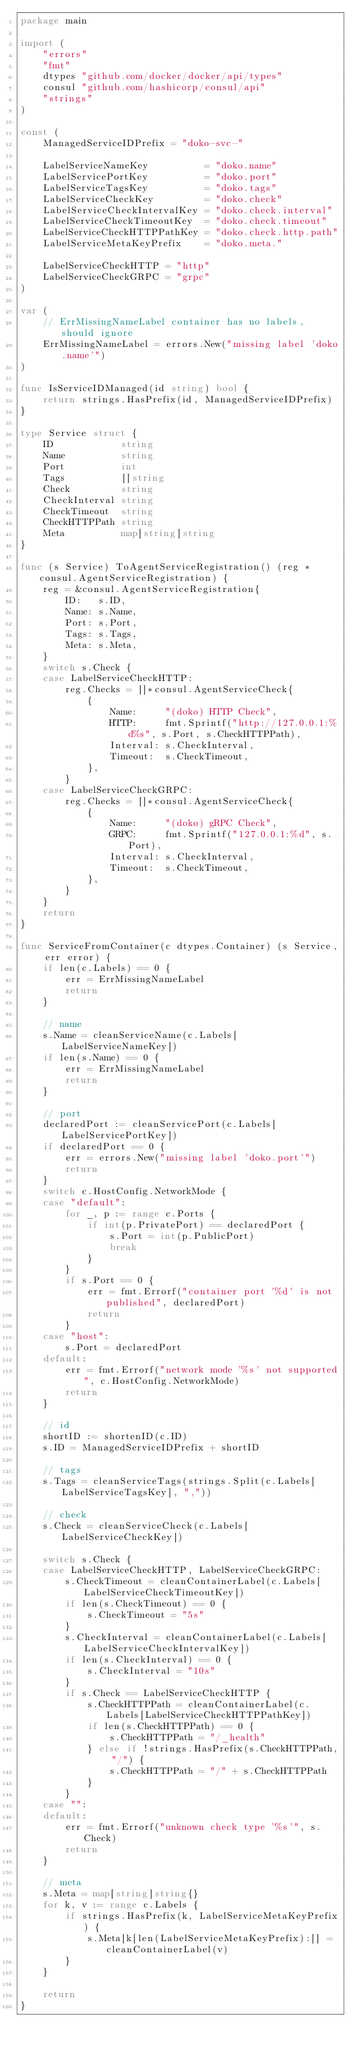Convert code to text. <code><loc_0><loc_0><loc_500><loc_500><_Go_>package main

import (
	"errors"
	"fmt"
	dtypes "github.com/docker/docker/api/types"
	consul "github.com/hashicorp/consul/api"
	"strings"
)

const (
	ManagedServiceIDPrefix = "doko-svc-"

	LabelServiceNameKey          = "doko.name"
	LabelServicePortKey          = "doko.port"
	LabelServiceTagsKey          = "doko.tags"
	LabelServiceCheckKey         = "doko.check"
	LabelServiceCheckIntervalKey = "doko.check.interval"
	LabelServiceCheckTimeoutKey  = "doko.check.timeout"
	LabelServiceCheckHTTPPathKey = "doko.check.http.path"
	LabelServiceMetaKeyPrefix    = "doko.meta."

	LabelServiceCheckHTTP = "http"
	LabelServiceCheckGRPC = "grpc"
)

var (
	// ErrMissingNameLabel container has no labels, should ignore
	ErrMissingNameLabel = errors.New("missing label 'doko.name'")
)

func IsServiceIDManaged(id string) bool {
	return strings.HasPrefix(id, ManagedServiceIDPrefix)
}

type Service struct {
	ID            string
	Name          string
	Port          int
	Tags          []string
	Check         string
	CheckInterval string
	CheckTimeout  string
	CheckHTTPPath string
	Meta          map[string]string
}

func (s Service) ToAgentServiceRegistration() (reg *consul.AgentServiceRegistration) {
	reg = &consul.AgentServiceRegistration{
		ID:   s.ID,
		Name: s.Name,
		Port: s.Port,
		Tags: s.Tags,
		Meta: s.Meta,
	}
	switch s.Check {
	case LabelServiceCheckHTTP:
		reg.Checks = []*consul.AgentServiceCheck{
			{
				Name:     "(doko) HTTP Check",
				HTTP:     fmt.Sprintf("http://127.0.0.1:%d%s", s.Port, s.CheckHTTPPath),
				Interval: s.CheckInterval,
				Timeout:  s.CheckTimeout,
			},
		}
	case LabelServiceCheckGRPC:
		reg.Checks = []*consul.AgentServiceCheck{
			{
				Name:     "(doko) gRPC Check",
				GRPC:     fmt.Sprintf("127.0.0.1:%d", s.Port),
				Interval: s.CheckInterval,
				Timeout:  s.CheckTimeout,
			},
		}
	}
	return
}

func ServiceFromContainer(c dtypes.Container) (s Service, err error) {
	if len(c.Labels) == 0 {
		err = ErrMissingNameLabel
		return
	}

	// name
	s.Name = cleanServiceName(c.Labels[LabelServiceNameKey])
	if len(s.Name) == 0 {
		err = ErrMissingNameLabel
		return
	}

	// port
	declaredPort := cleanServicePort(c.Labels[LabelServicePortKey])
	if declaredPort == 0 {
		err = errors.New("missing label 'doko.port'")
		return
	}
	switch c.HostConfig.NetworkMode {
	case "default":
		for _, p := range c.Ports {
			if int(p.PrivatePort) == declaredPort {
				s.Port = int(p.PublicPort)
				break
			}
		}
		if s.Port == 0 {
			err = fmt.Errorf("container port '%d' is not published", declaredPort)
			return
		}
	case "host":
		s.Port = declaredPort
	default:
		err = fmt.Errorf("network mode '%s' not supported", c.HostConfig.NetworkMode)
		return
	}

	// id
	shortID := shortenID(c.ID)
	s.ID = ManagedServiceIDPrefix + shortID

	// tags
	s.Tags = cleanServiceTags(strings.Split(c.Labels[LabelServiceTagsKey], ","))

	// check
	s.Check = cleanServiceCheck(c.Labels[LabelServiceCheckKey])

	switch s.Check {
	case LabelServiceCheckHTTP, LabelServiceCheckGRPC:
		s.CheckTimeout = cleanContainerLabel(c.Labels[LabelServiceCheckTimeoutKey])
		if len(s.CheckTimeout) == 0 {
			s.CheckTimeout = "5s"
		}
		s.CheckInterval = cleanContainerLabel(c.Labels[LabelServiceCheckIntervalKey])
		if len(s.CheckInterval) == 0 {
			s.CheckInterval = "10s"
		}
		if s.Check == LabelServiceCheckHTTP {
			s.CheckHTTPPath = cleanContainerLabel(c.Labels[LabelServiceCheckHTTPPathKey])
			if len(s.CheckHTTPPath) == 0 {
				s.CheckHTTPPath = "/_health"
			} else if !strings.HasPrefix(s.CheckHTTPPath, "/") {
				s.CheckHTTPPath = "/" + s.CheckHTTPPath
			}
		}
	case "":
	default:
		err = fmt.Errorf("unknown check type '%s'", s.Check)
		return
	}

	// meta
	s.Meta = map[string]string{}
	for k, v := range c.Labels {
		if strings.HasPrefix(k, LabelServiceMetaKeyPrefix) {
			s.Meta[k[len(LabelServiceMetaKeyPrefix):]] = cleanContainerLabel(v)
		}
	}

	return
}
</code> 